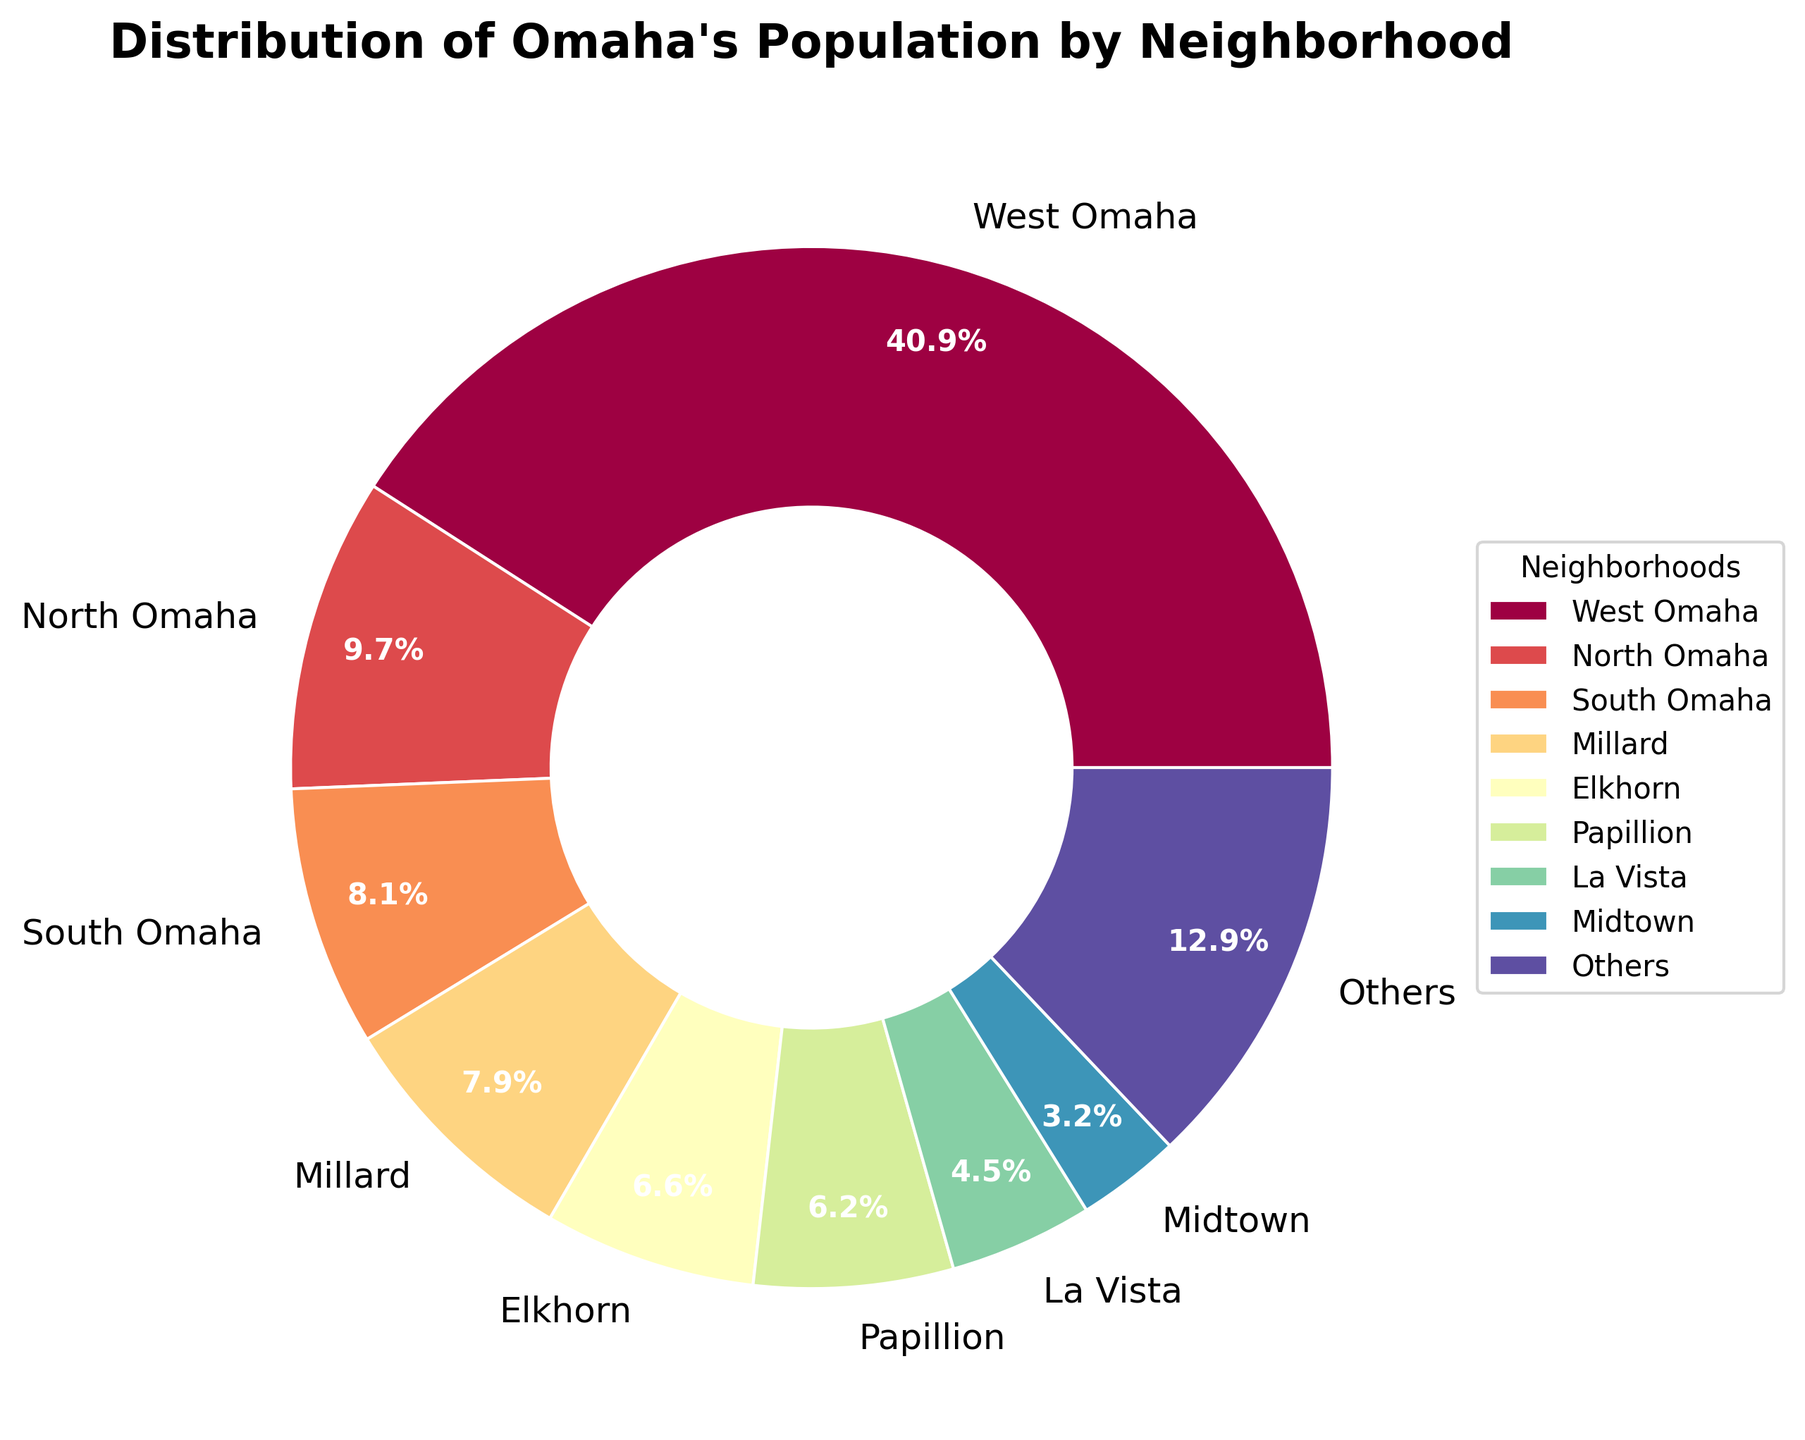What percentage of Omaha's population lives in "West Omaha"? Look at the segment labeled "West Omaha" and note its percentage.
Answer: 53.1% Which neighborhood has the second-largest population percentage? Identify the segment with the second-largest slice after "West Omaha"; it is labeled "North Omaha".
Answer: North Omaha How many neighborhoods are grouped under "Others" in the pie chart? Count all neighborhoods beyond the top 8. They are grouped into "Others".
Answer: 7 Compare the population percentage of "Midtown" with "South Omaha". Which is higher? Note the percentage labels for "Midtown" and "South Omaha" and compare them. "South Omaha" has a larger slice than "Midtown".
Answer: South Omaha What is the combined percentage of "Downtown" and "Aksarben"? Sum the percentage values for "Downtown" and "Aksarben".
Answer: 2.0% + 2.3% = 4.3% Is "Florence" among the top 8 neighborhoods by population percentage? Confirm if "Florence" is one of the labeled segments in the top 8 slices before "Others".
Answer: Yes Which neighborhood has the smallest population percentage among the top 8 labeled? Identify the smallest slice among the labeled top 8 segments. "Dundee" has the smallest percentage.
Answer: Dundee What is the difference in population percentage between "Millard" and "Midtown"? Calculate the difference between "Millard" percentage and "Midtown" percentage.
Answer: 10.2% - 4.2% = 6.0% What color is associated with the "Old Market" segment? Observe the color of the segment labeled "Old Market".
Answer: Light blue How does the percentage of "Ralston" compare to "La Vista"? Check the segments labeled "Ralston" and "La Vista" and compare their percentages. "Ralston" has a smaller percentage than "La Vista".
Answer: La Vista 